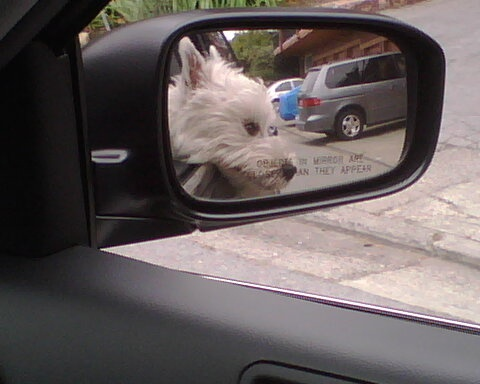Describe the objects in this image and their specific colors. I can see car in black and gray tones, dog in black, darkgray, gray, and lightgray tones, car in black, gray, and darkgray tones, car in black, gray, and darkgray tones, and car in black, gray, white, and purple tones in this image. 